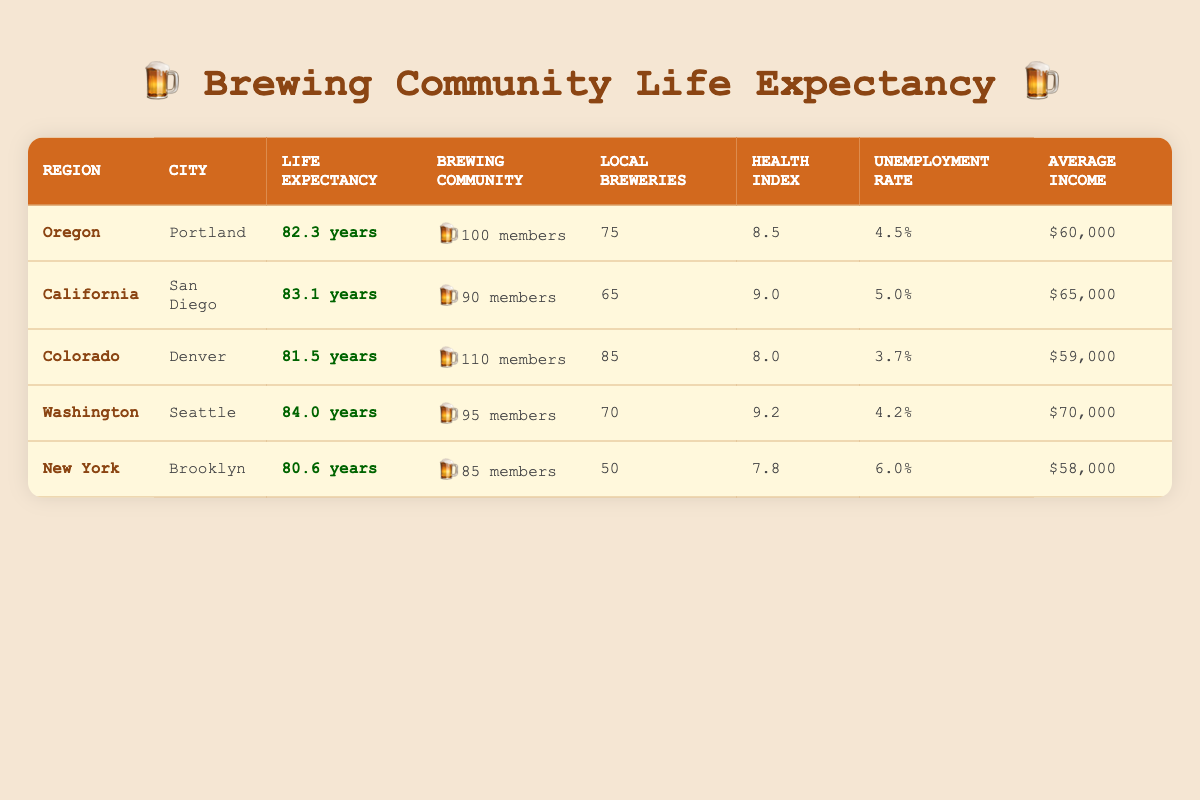What is the average life expectancy in Portland? The table shows that the average life expectancy in Portland, Oregon is listed as 82.3 years.
Answer: 82.3 years Which city has the highest health index? Upon examining the health index values in the table, Seattle has the highest health index at 9.2, compared to the others.
Answer: Seattle What is the difference in average life expectancy between Seattle and Brooklyn? To find the difference, subtract Brooklyn's average life expectancy of 80.6 years from Seattle's 84.0 years: 84.0 - 80.6 = 3.4 years.
Answer: 3.4 years Is the average income in California higher than that in Oregon? Comparing the average income values, California's average income is $65,000, while Oregon's is $60,000, indicating that California's average income is higher.
Answer: Yes How many local breweries are there on average across all cities? To calculate the average number of local breweries, sum the local breweries count (75 + 65 + 85 + 70 + 50 = 345) and divide by the number of cities (5): 345/5 = 69.
Answer: 69 What is the total brewing community size in Colorado and Washington combined? Adding the brewing community sizes for Colorado (110) and Washington (95) gives: 110 + 95 = 205.
Answer: 205 Which region has the highest average life expectancy among the listed cities? Comparing life expectancies, San Diego (83.1 years) has the highest average life expectancy, followed closely by Seattle (84.0 years).
Answer: Seattle Is the unemployment rate in Brooklyn the highest among the listed regions? The unemployment rate in Brooklyn is 6.0%, and comparing it with others: Oregon (4.5%), California (5.0%), Colorado (3.7%), and Washington (4.2%), confirms that Brooklyn has the highest rate.
Answer: Yes 